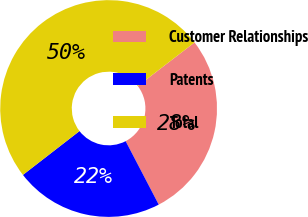<chart> <loc_0><loc_0><loc_500><loc_500><pie_chart><fcel>Customer Relationships<fcel>Patents<fcel>Total<nl><fcel>27.78%<fcel>22.16%<fcel>50.06%<nl></chart> 